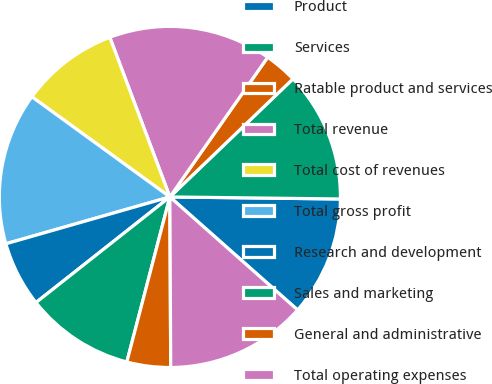<chart> <loc_0><loc_0><loc_500><loc_500><pie_chart><fcel>Product<fcel>Services<fcel>Ratable product and services<fcel>Total revenue<fcel>Total cost of revenues<fcel>Total gross profit<fcel>Research and development<fcel>Sales and marketing<fcel>General and administrative<fcel>Total operating expenses<nl><fcel>11.34%<fcel>12.36%<fcel>3.11%<fcel>15.45%<fcel>9.28%<fcel>14.42%<fcel>6.2%<fcel>10.31%<fcel>4.14%<fcel>13.39%<nl></chart> 